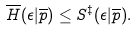<formula> <loc_0><loc_0><loc_500><loc_500>\overline { H } ( \epsilon | \overline { p } ) \leq S ^ { \ddagger } ( \epsilon | \overline { p } ) .</formula> 